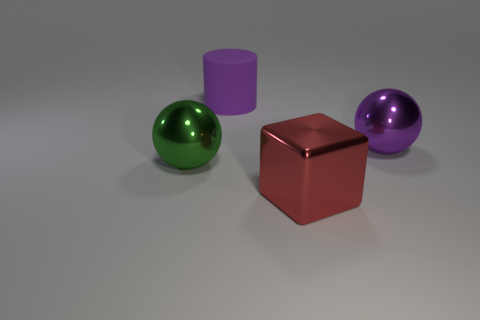Add 4 big red things. How many objects exist? 8 Subtract all cylinders. How many objects are left? 3 Subtract all green spheres. How many spheres are left? 1 Add 2 tiny purple matte blocks. How many tiny purple matte blocks exist? 2 Subtract 0 purple cubes. How many objects are left? 4 Subtract 1 cylinders. How many cylinders are left? 0 Subtract all yellow cubes. Subtract all brown cylinders. How many cubes are left? 1 Subtract all red balls. How many yellow cylinders are left? 0 Subtract all tiny blue matte blocks. Subtract all large balls. How many objects are left? 2 Add 1 large spheres. How many large spheres are left? 3 